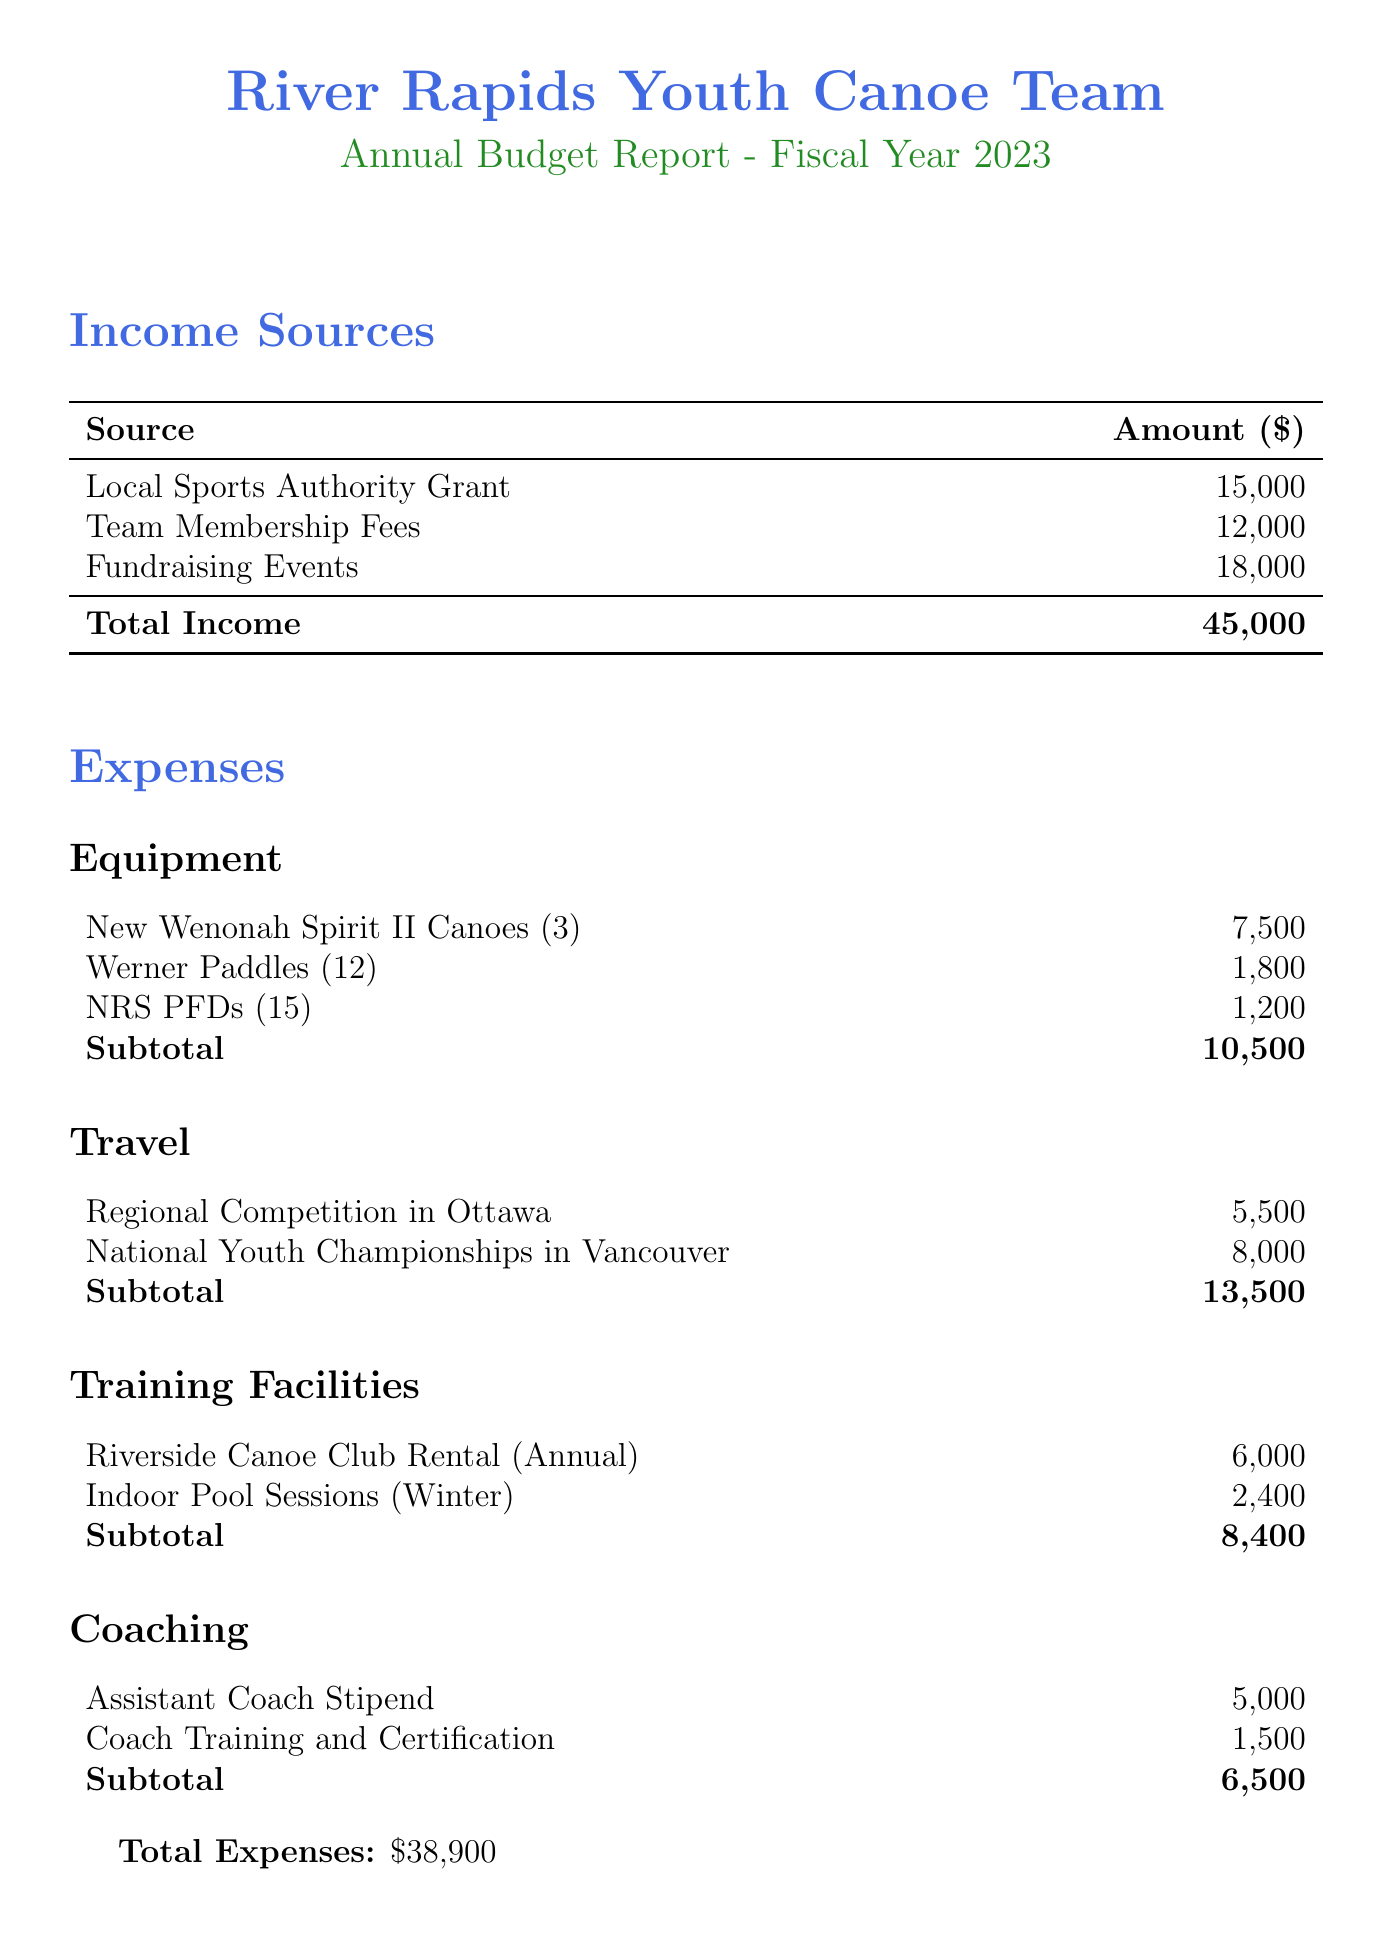what is the total budget for the fiscal year 2023? The total budget is listed prominently in the document, specifically under the budget section.
Answer: 45000 how much is allocated for equipment costs? The equipment costs are detailed under the expenses section, summing the costs of individual items.
Answer: 10500 what is the amount for travel expenses? The travel expenses can be found in the expenses section, detailing the costs for competitions.
Answer: 13500 how much do the team membership fees contribute to income? The income sources section specifies the amount derived from team membership fees.
Answer: 12000 what is the cost of the Riverside Canoe Club Rental? This specific rental cost is mentioned under the training facilities expenses category.
Answer: 6000 what percentage increase was set for fundraising targets compared to last year? The notes section indicates the percentage increase for fundraising targets from the previous year.
Answer: 20% what is the total amount spent on coaching? The coaching expenses are detailed under the coaching category, summing the individual costs.
Answer: 6500 what is the subtotal for training facilities? The subtotal for training facilities is calculated by summing the rental costs listed under that category.
Answer: 8400 